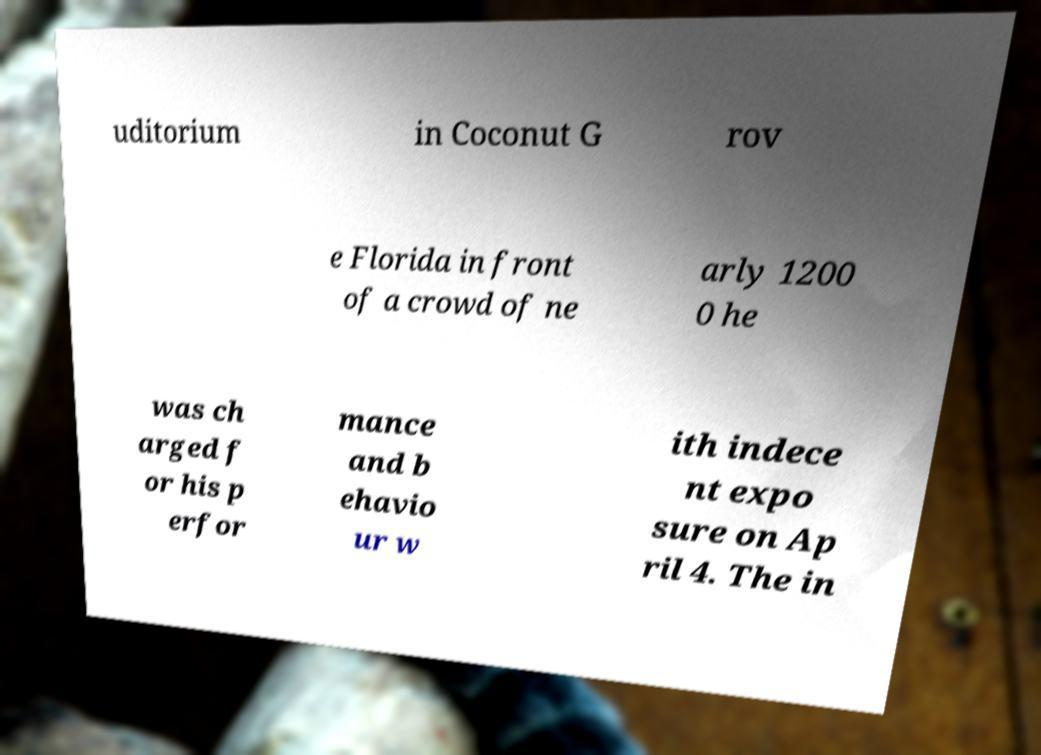Could you assist in decoding the text presented in this image and type it out clearly? uditorium in Coconut G rov e Florida in front of a crowd of ne arly 1200 0 he was ch arged f or his p erfor mance and b ehavio ur w ith indece nt expo sure on Ap ril 4. The in 